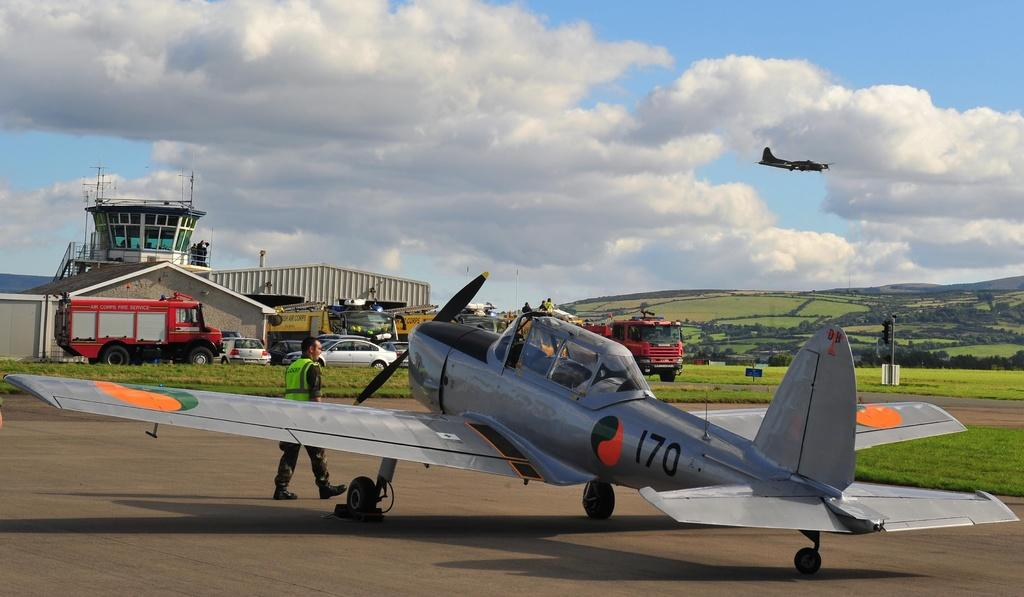<image>
Write a terse but informative summary of the picture. A silver airplane has 170 near the tail. 